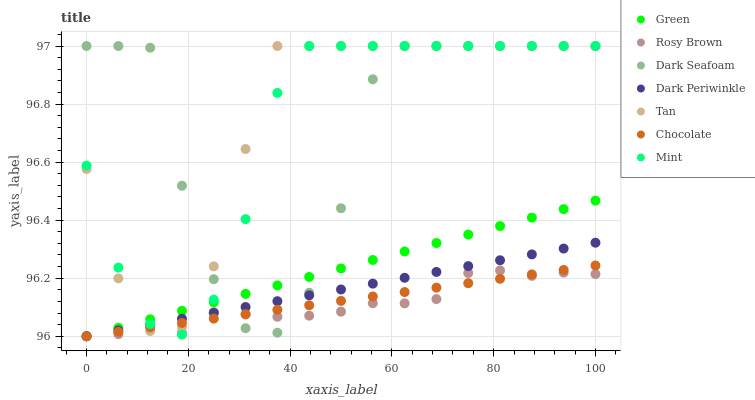Does Rosy Brown have the minimum area under the curve?
Answer yes or no. Yes. Does Tan have the maximum area under the curve?
Answer yes or no. Yes. Does Chocolate have the minimum area under the curve?
Answer yes or no. No. Does Chocolate have the maximum area under the curve?
Answer yes or no. No. Is Dark Periwinkle the smoothest?
Answer yes or no. Yes. Is Dark Seafoam the roughest?
Answer yes or no. Yes. Is Chocolate the smoothest?
Answer yes or no. No. Is Chocolate the roughest?
Answer yes or no. No. Does Rosy Brown have the lowest value?
Answer yes or no. Yes. Does Dark Seafoam have the lowest value?
Answer yes or no. No. Does Mint have the highest value?
Answer yes or no. Yes. Does Chocolate have the highest value?
Answer yes or no. No. Does Mint intersect Dark Seafoam?
Answer yes or no. Yes. Is Mint less than Dark Seafoam?
Answer yes or no. No. Is Mint greater than Dark Seafoam?
Answer yes or no. No. 